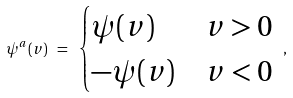<formula> <loc_0><loc_0><loc_500><loc_500>\psi ^ { a } ( v ) \ = \ \begin{cases} \psi ( v ) & v > 0 \\ - \psi ( v ) & v < 0 \end{cases} \ ,</formula> 